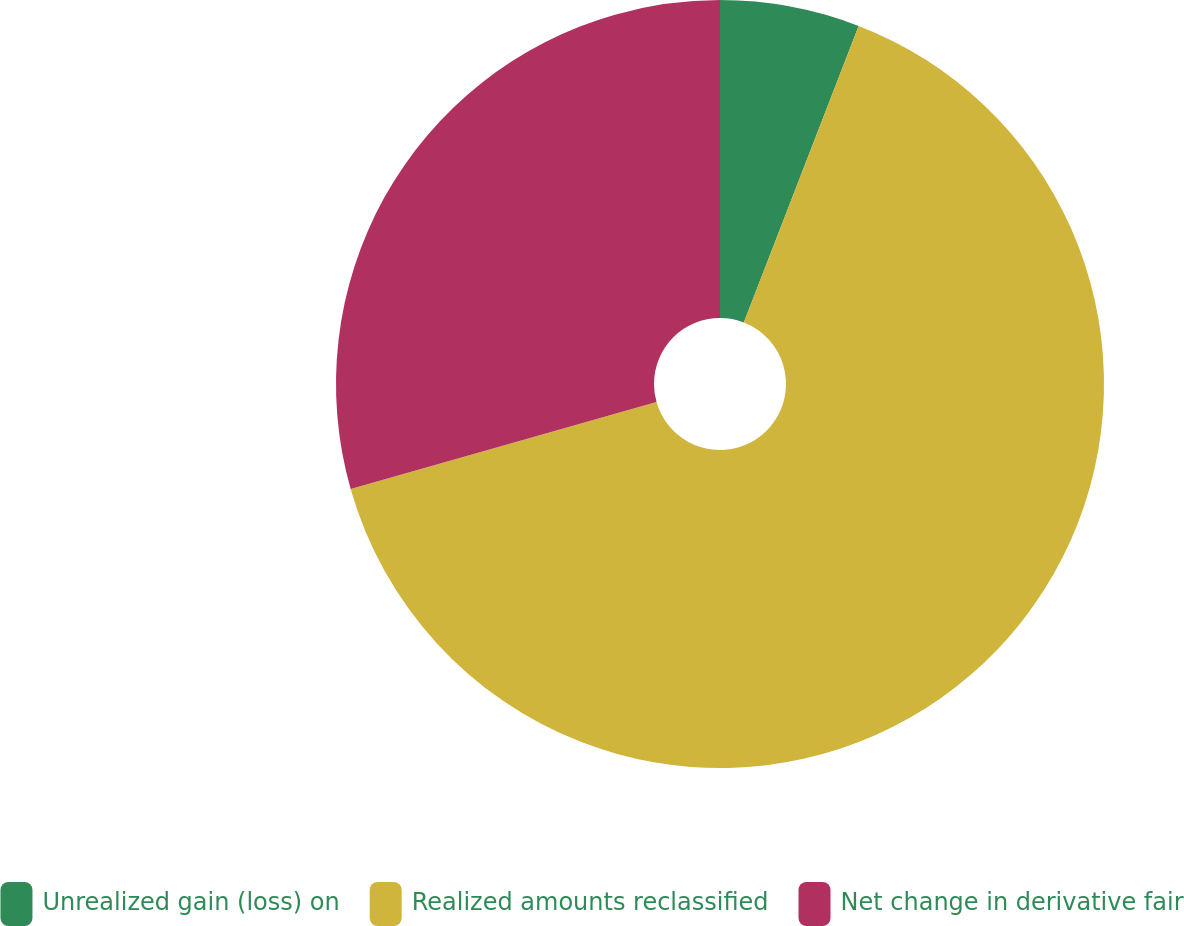Convert chart to OTSL. <chart><loc_0><loc_0><loc_500><loc_500><pie_chart><fcel>Unrealized gain (loss) on<fcel>Realized amounts reclassified<fcel>Net change in derivative fair<nl><fcel>5.88%<fcel>64.71%<fcel>29.41%<nl></chart> 